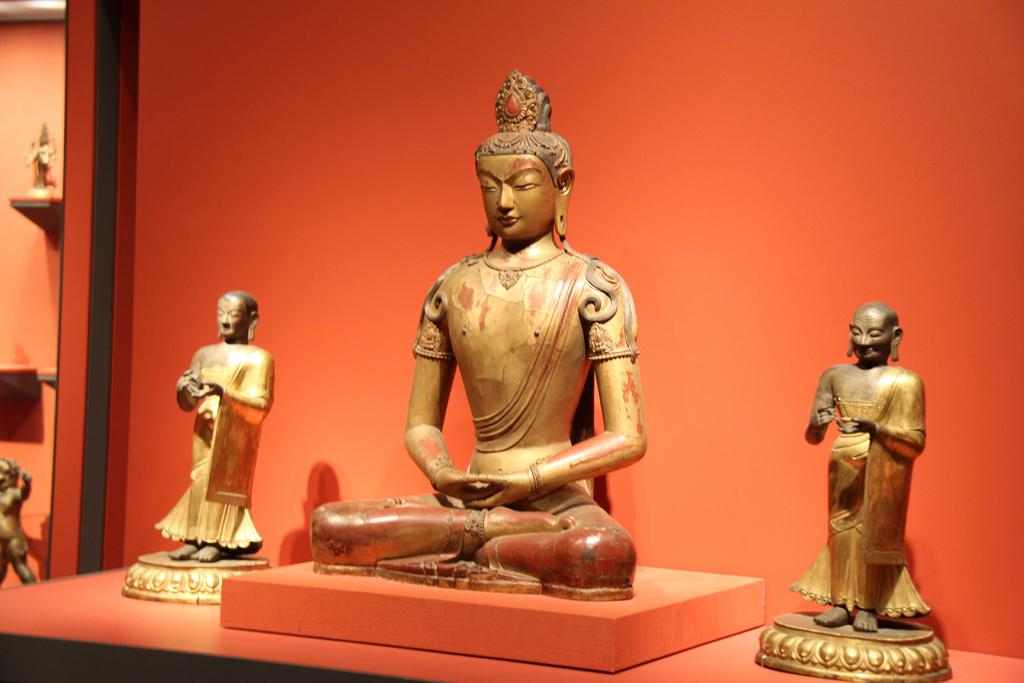What type of art is present in the image? There are sculptures in the image. What is the background of the image? There is a wall in the image. Where is the toad sitting on the sofa in the image? There is no toad or sofa present in the image; it only features sculptures and a wall. 